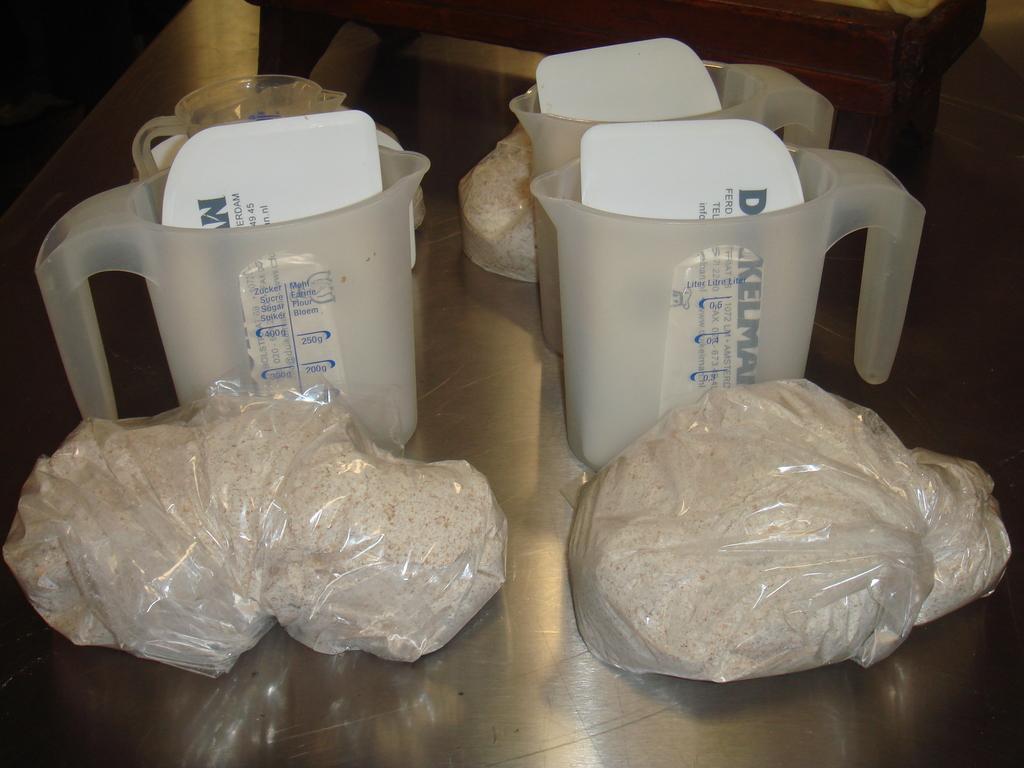Please provide a concise description of this image. In this image we can see plastic bags with some object and there are jars with papers inside the jar on the floor and in the background there is an object looks like a table. 